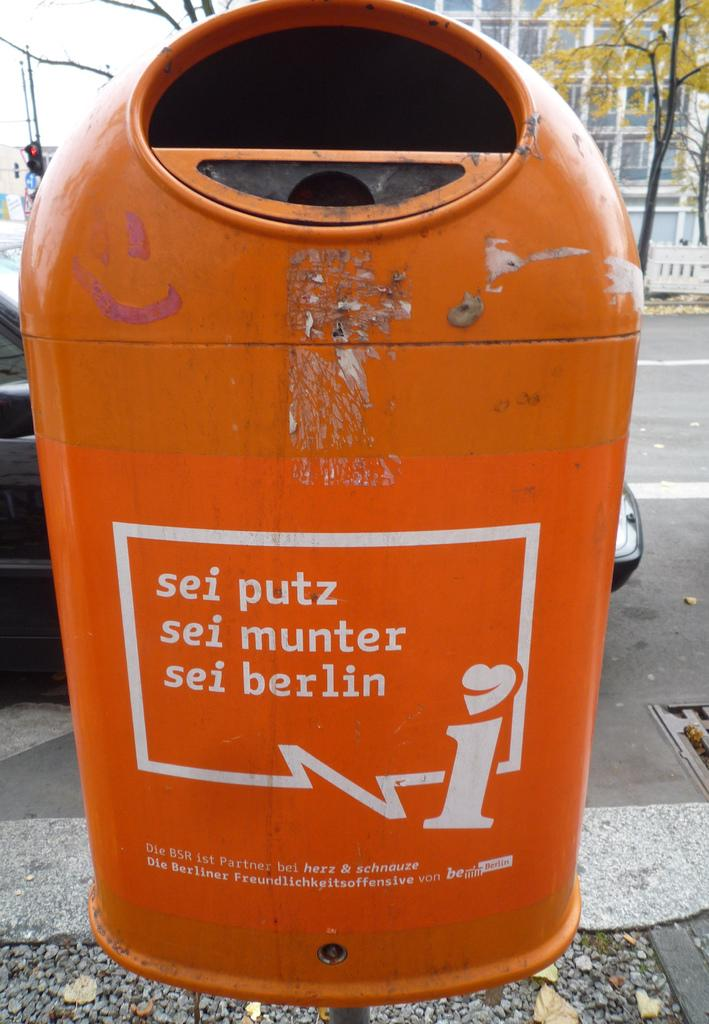<image>
Render a clear and concise summary of the photo. Orange mailbox which says "sei putz" on the top. 